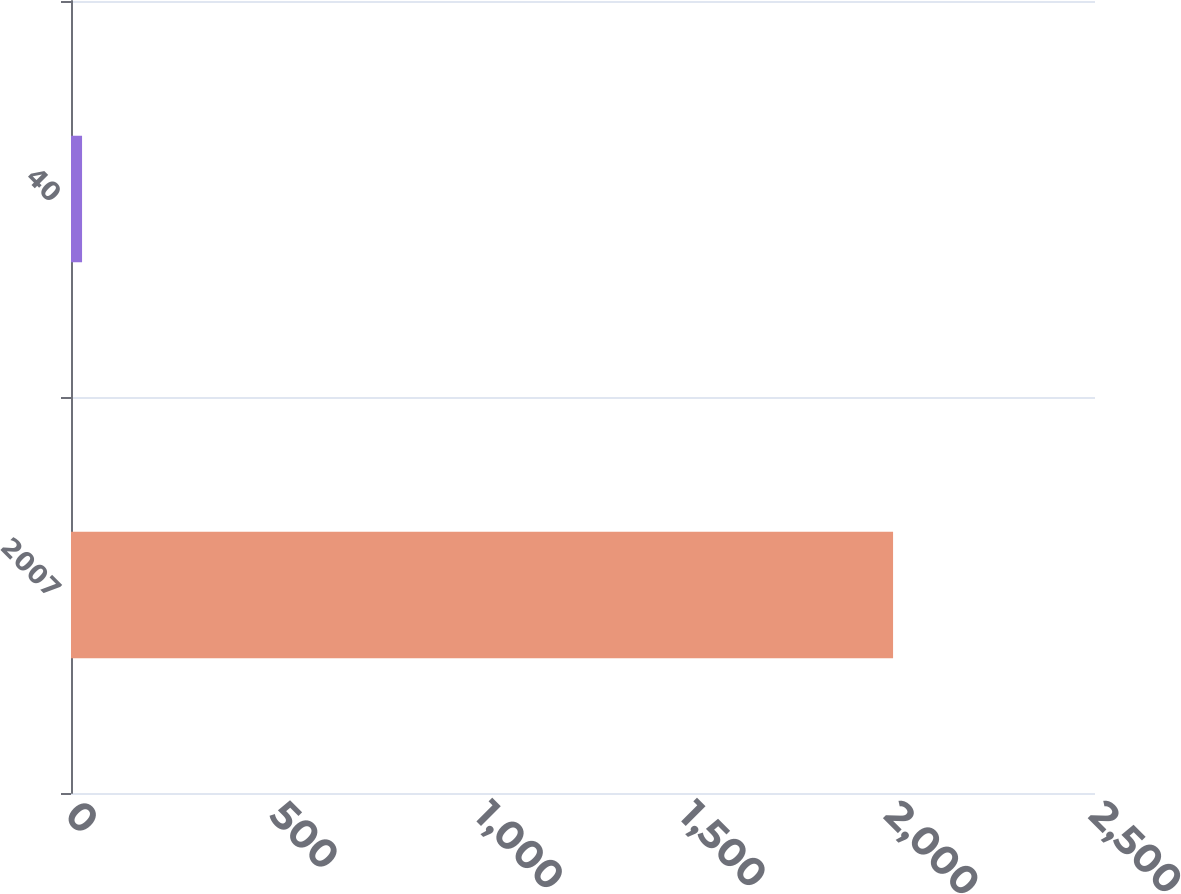Convert chart. <chart><loc_0><loc_0><loc_500><loc_500><bar_chart><fcel>2007<fcel>40<nl><fcel>2007<fcel>27<nl></chart> 